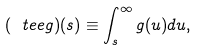<formula> <loc_0><loc_0><loc_500><loc_500>( \ t e e { g } ) ( s ) \equiv \int _ { s } ^ { \infty } g ( u ) d u ,</formula> 